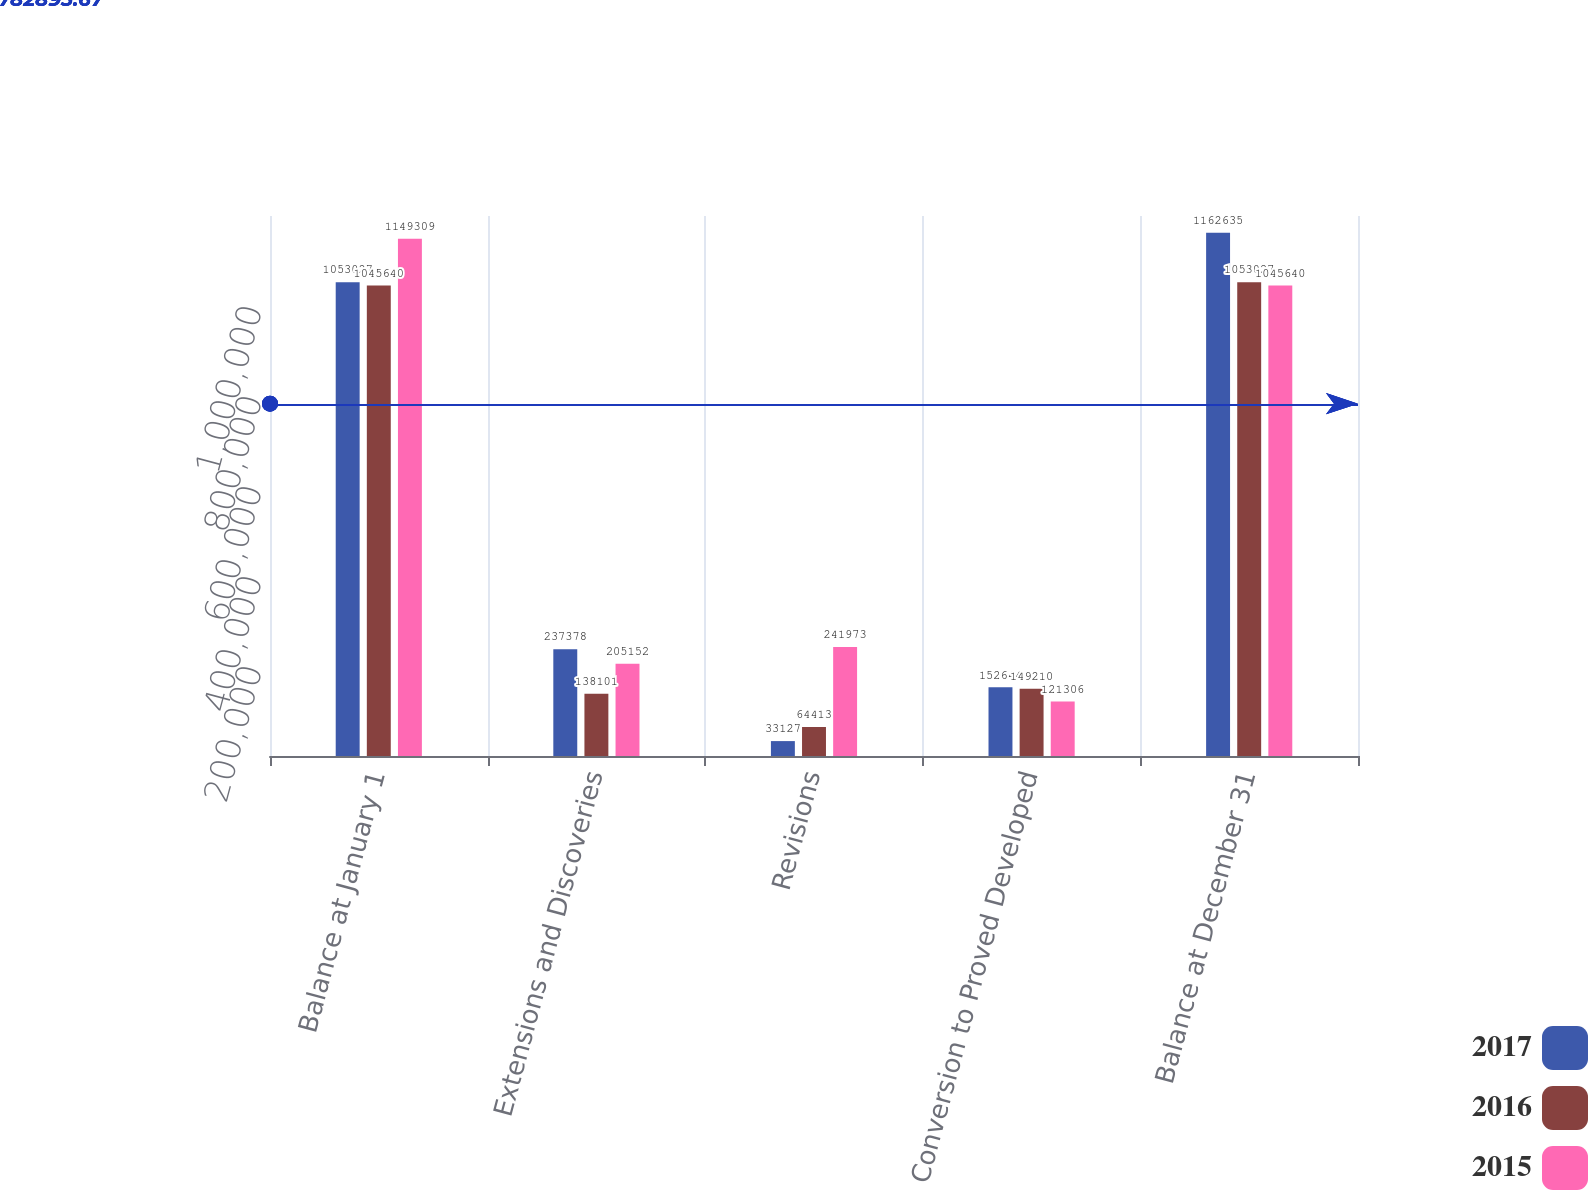<chart> <loc_0><loc_0><loc_500><loc_500><stacked_bar_chart><ecel><fcel>Balance at January 1<fcel>Extensions and Discoveries<fcel>Revisions<fcel>Conversion to Proved Developed<fcel>Balance at December 31<nl><fcel>2017<fcel>1.05303e+06<fcel>237378<fcel>33127<fcel>152644<fcel>1.16264e+06<nl><fcel>2016<fcel>1.04564e+06<fcel>138101<fcel>64413<fcel>149210<fcel>1.05303e+06<nl><fcel>2015<fcel>1.14931e+06<fcel>205152<fcel>241973<fcel>121306<fcel>1.04564e+06<nl></chart> 